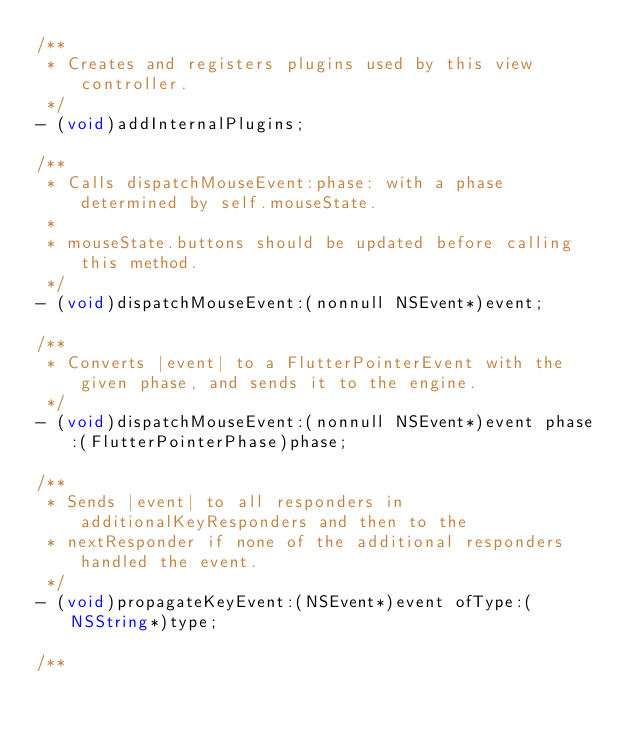<code> <loc_0><loc_0><loc_500><loc_500><_ObjectiveC_>/**
 * Creates and registers plugins used by this view controller.
 */
- (void)addInternalPlugins;

/**
 * Calls dispatchMouseEvent:phase: with a phase determined by self.mouseState.
 *
 * mouseState.buttons should be updated before calling this method.
 */
- (void)dispatchMouseEvent:(nonnull NSEvent*)event;

/**
 * Converts |event| to a FlutterPointerEvent with the given phase, and sends it to the engine.
 */
- (void)dispatchMouseEvent:(nonnull NSEvent*)event phase:(FlutterPointerPhase)phase;

/**
 * Sends |event| to all responders in additionalKeyResponders and then to the
 * nextResponder if none of the additional responders handled the event.
 */
- (void)propagateKeyEvent:(NSEvent*)event ofType:(NSString*)type;

/**</code> 